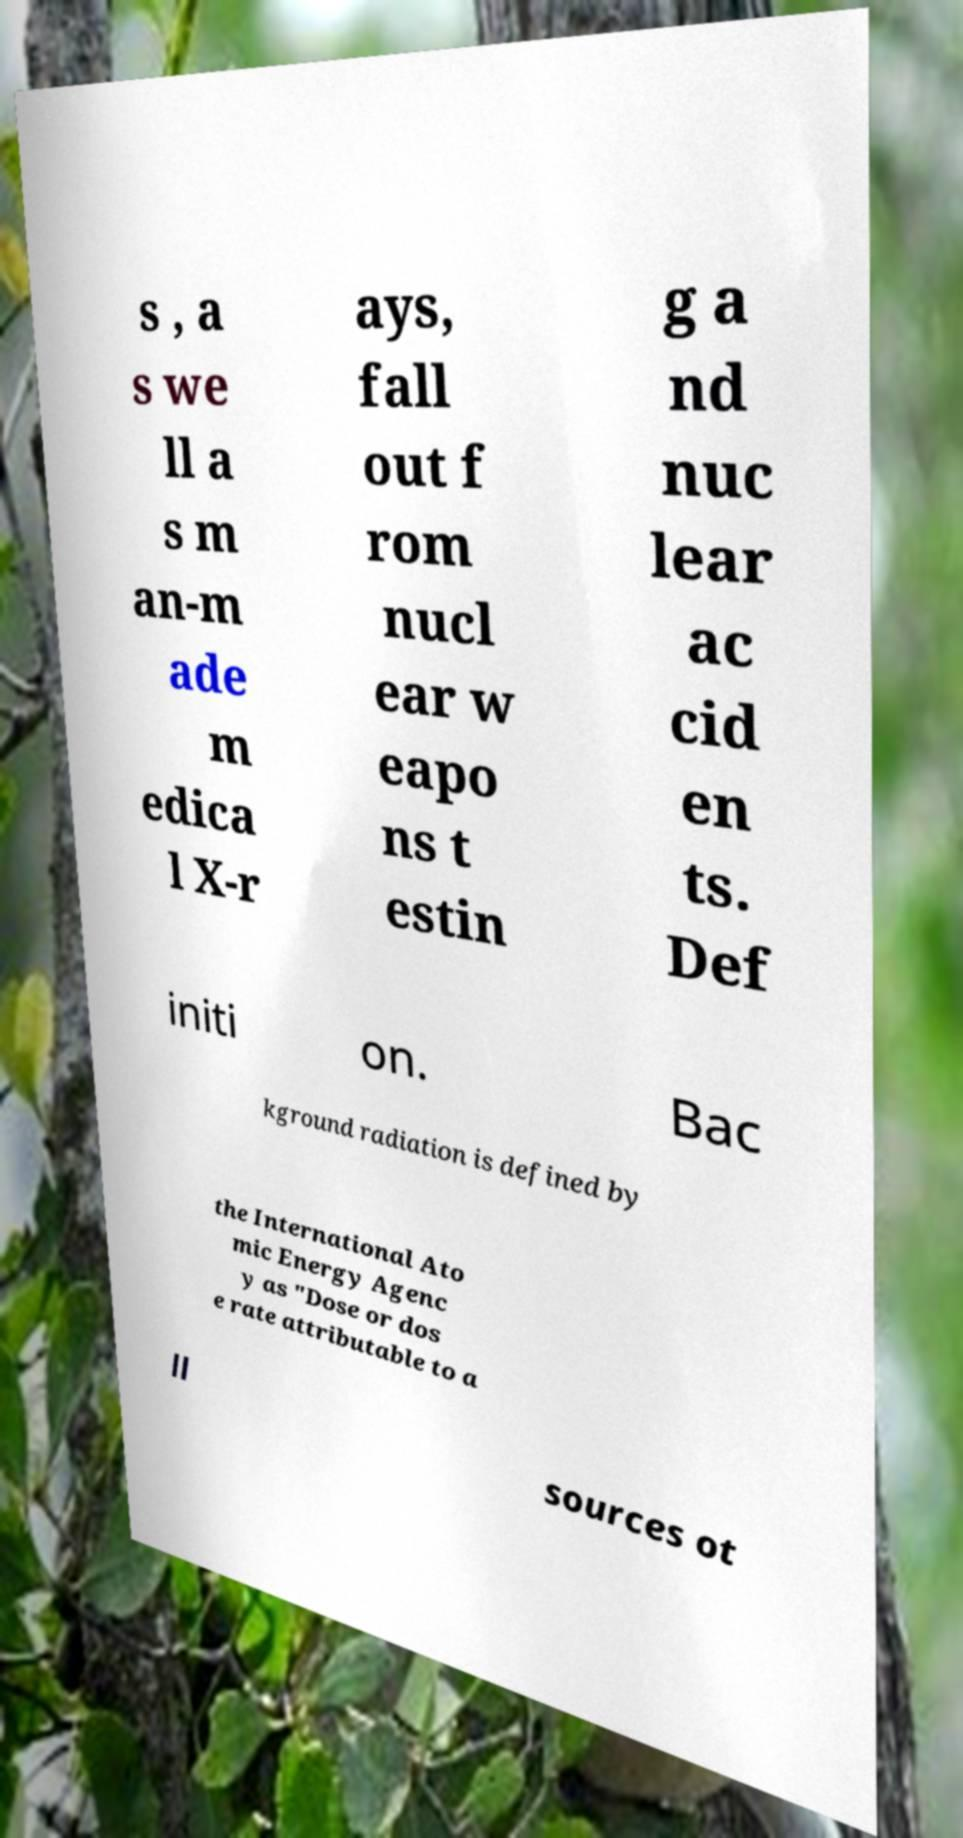What messages or text are displayed in this image? I need them in a readable, typed format. s , a s we ll a s m an-m ade m edica l X-r ays, fall out f rom nucl ear w eapo ns t estin g a nd nuc lear ac cid en ts. Def initi on. Bac kground radiation is defined by the International Ato mic Energy Agenc y as "Dose or dos e rate attributable to a ll sources ot 